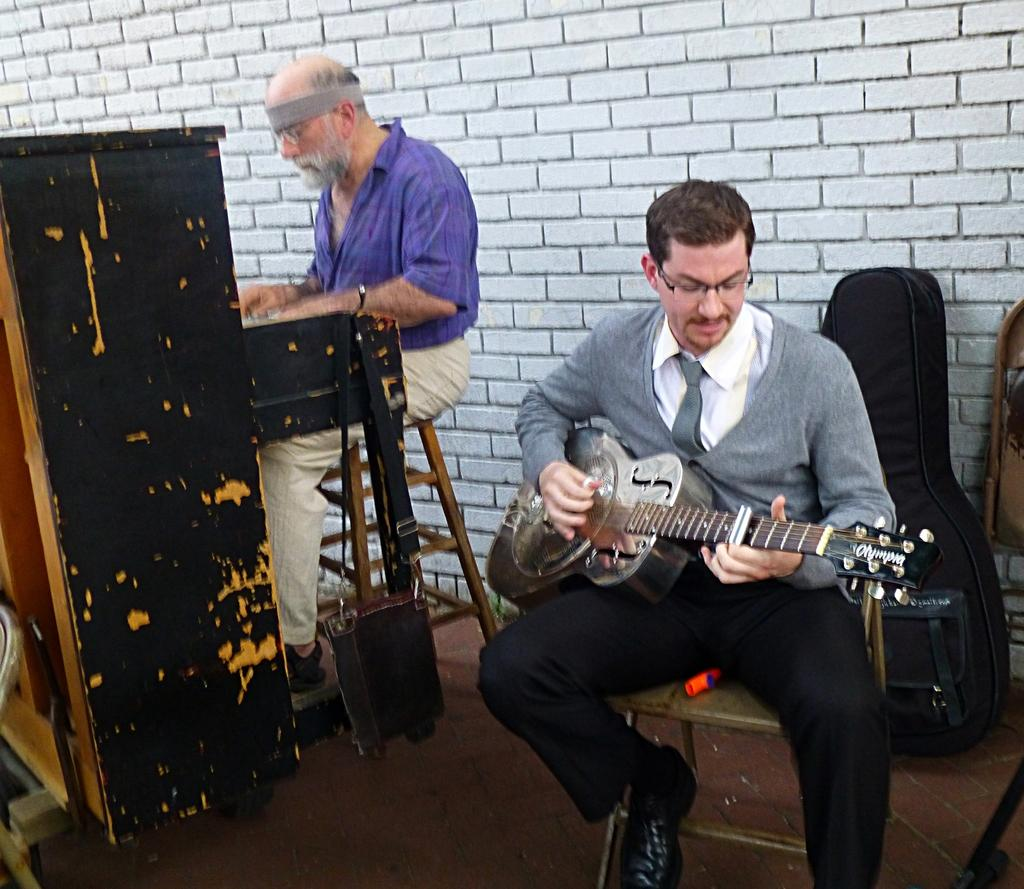What is the person on the left side of the image doing? The person on the left is playing the piano. What is the person on the right side of the image doing? The person on the right is playing the guitar. How many people are playing musical instruments in the image? There are two people playing musical instruments in the image. Can you see any dinosaurs playing with a jar in the image? No, there are no dinosaurs or jars present in the image. 